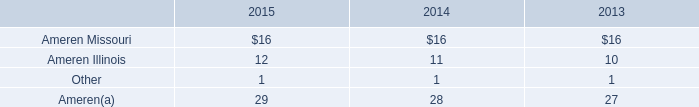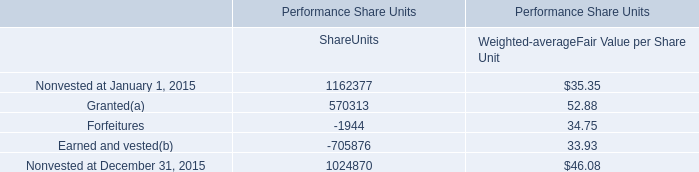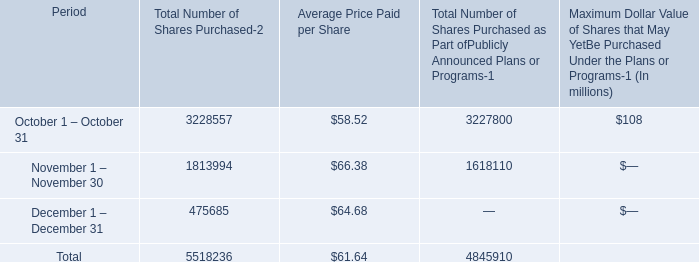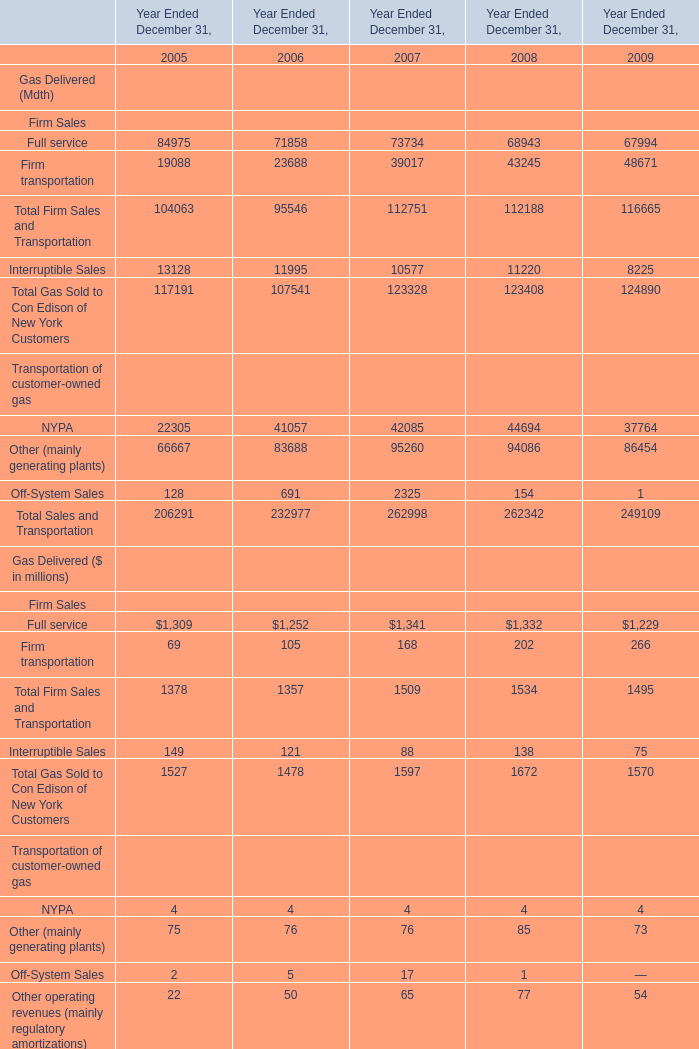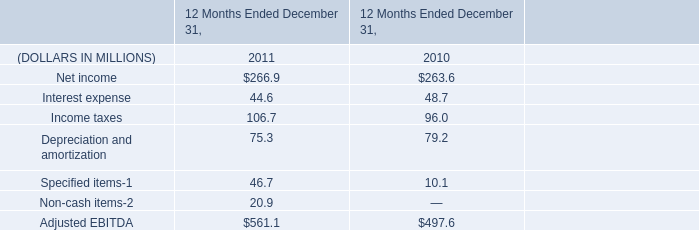What is the sum of Other operating revenues (mainly regulatory amortizations) in 2006 and Interest expense in 2011? (in million) 
Computations: (50 + 44.6)
Answer: 94.6. 